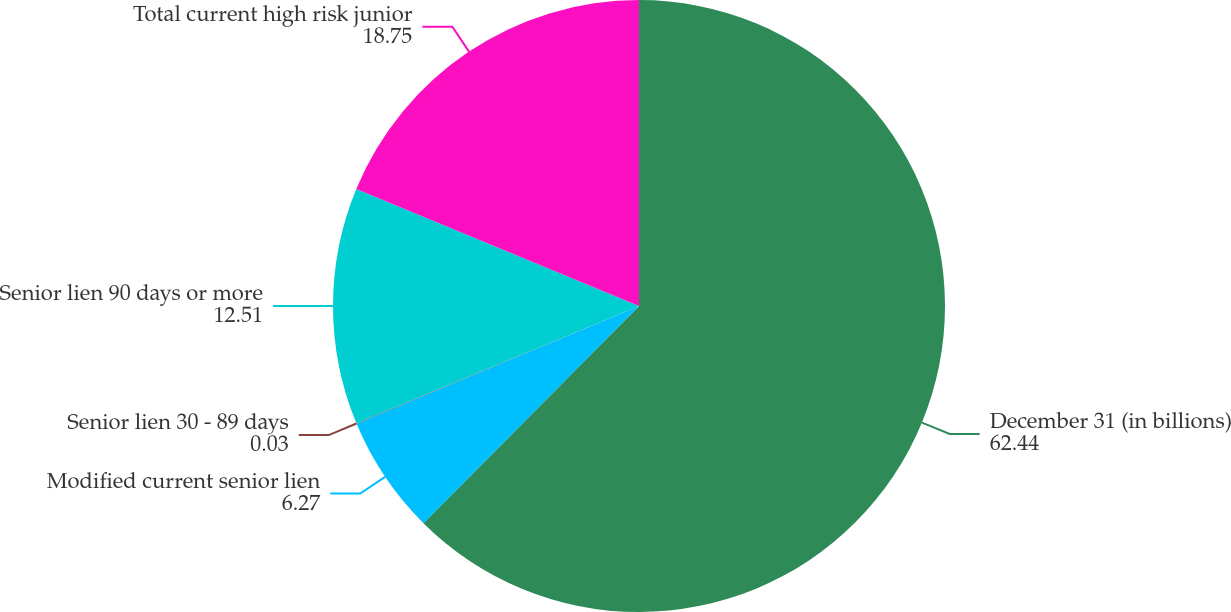Convert chart. <chart><loc_0><loc_0><loc_500><loc_500><pie_chart><fcel>December 31 (in billions)<fcel>Modified current senior lien<fcel>Senior lien 30 - 89 days<fcel>Senior lien 90 days or more<fcel>Total current high risk junior<nl><fcel>62.44%<fcel>6.27%<fcel>0.03%<fcel>12.51%<fcel>18.75%<nl></chart> 